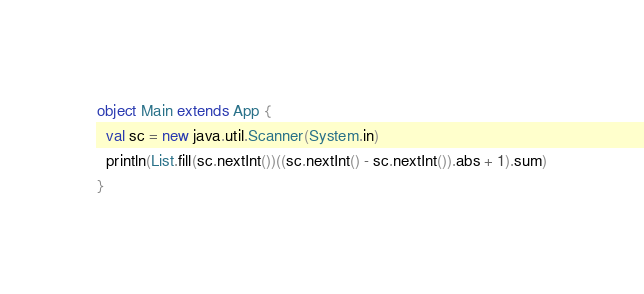Convert code to text. <code><loc_0><loc_0><loc_500><loc_500><_Scala_>object Main extends App {
  val sc = new java.util.Scanner(System.in)
  println(List.fill(sc.nextInt())((sc.nextInt() - sc.nextInt()).abs + 1).sum)
}
</code> 